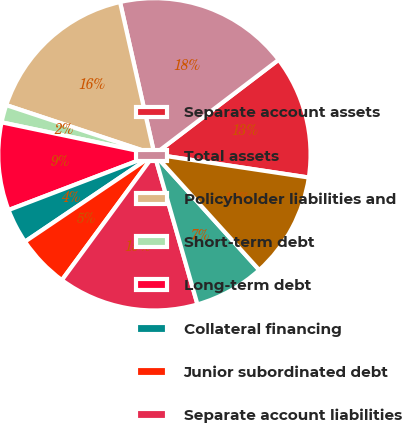<chart> <loc_0><loc_0><loc_500><loc_500><pie_chart><fcel>Separate account assets<fcel>Total assets<fcel>Policyholder liabilities and<fcel>Short-term debt<fcel>Long-term debt<fcel>Collateral financing<fcel>Junior subordinated debt<fcel>Separate account liabilities<fcel>Accumulated other<fcel>Total MetLife Inc's<nl><fcel>12.73%<fcel>18.18%<fcel>16.36%<fcel>1.82%<fcel>9.09%<fcel>3.64%<fcel>5.46%<fcel>14.54%<fcel>7.27%<fcel>10.91%<nl></chart> 